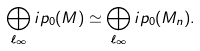<formula> <loc_0><loc_0><loc_500><loc_500>\bigoplus _ { \ell _ { \infty } } \L i p _ { 0 } ( M ) \simeq \bigoplus _ { \ell _ { \infty } } \L i p _ { 0 } ( M _ { n } ) .</formula> 